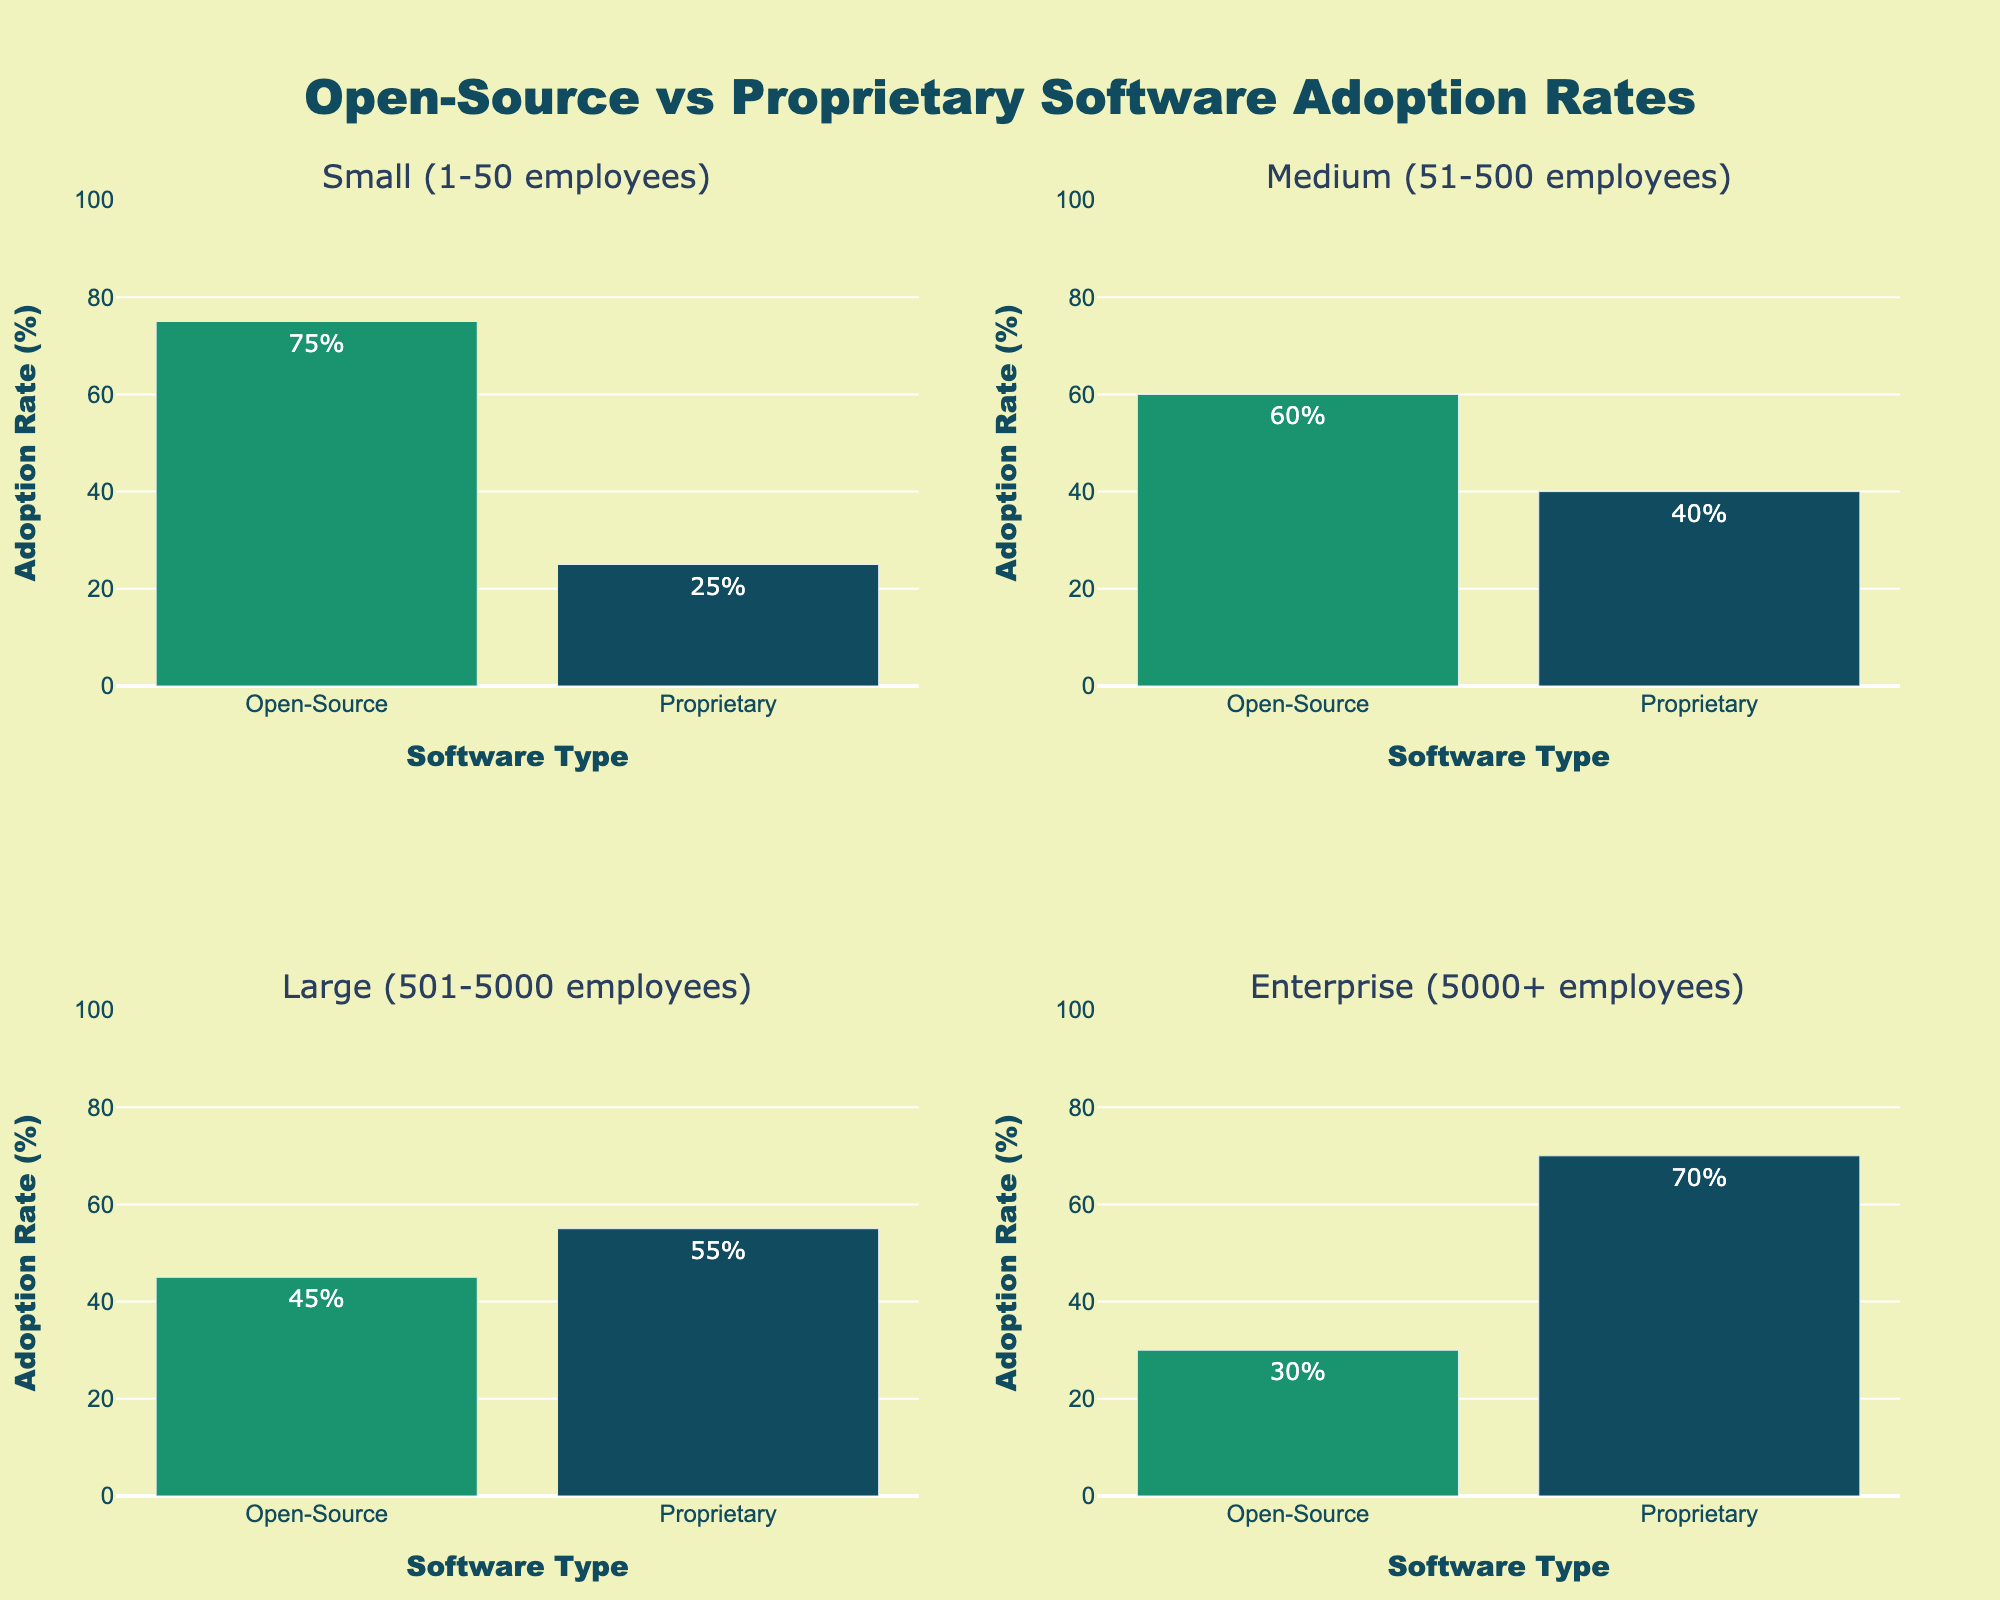What is the title of the figure? The title is located at the top center of the figure. It reads "Open-Source vs Proprietary Software Adoption Rates," which indicates that the figure compares the adoption rates of open-source software versus proprietary software in different company sizes.
Answer: Open-Source vs Proprietary Software Adoption Rates How is the 'Small' company size adoption rate distributed between Open-Source and Proprietary software? Looking at the subplot titled "Small (1-50 employees)," the bar for Open-Source is at 75%, and the bar for Proprietary is at 25%, indicating the distribution of adoption rates.
Answer: 75% Open-Source, 25% Proprietary Which company size has the highest adoption rate of proprietary software? By analyzing the heights of the bars representing proprietary software in each subplot, the "Enterprise (5000+ employees)" subplot has the highest adoption rate at 70%.
Answer: Enterprise (5000+ employees) What is the difference in Open-Source adoption rates between Medium and Large companies? The Open-Source adoption rate for Medium companies is 60%, and for Large companies, it is 45%. The difference is calculated as 60% - 45% = 15%.
Answer: 15% Which company size shows a greater preference for open-source software over proprietary software? In the "Small (1-50 employees)" subplot, the Open-Source adoption rate (75%) is significantly higher than the Proprietary adoption rate (25%), indicating a greater preference for open-source software.
Answer: Small (1-50 employees) What is the total adoption rate (sum of Open-Source and Proprietary) for Medium companies? Adding the Open-Source adoption rate (60%) with the Proprietary adoption rate (40%) for Medium companies, the total is 60% + 40% = 100%.
Answer: 100% How does the adoption rate of proprietary software in Large companies compare with that in Enterprise companies? Comparing the "Large (501-5000 employees)" subplot with the 55% proprietary adoption rate and the "Enterprise (5000+ employees)" subplot with the 70% proprietary adoption rate, it is clear that the Enterprise companies have a higher adoption rate for proprietary software.
Answer: Enterprise companies have a higher adoption rate What are the adoption rates of Open-Source and Proprietary software in the subplot located at the top right corner? The subplot at the top right is titled "Medium (51-500 employees)." The Open-Source rate is 60%, and the Proprietary rate is 40%.
Answer: 60% Open-Source, 40% Proprietary 